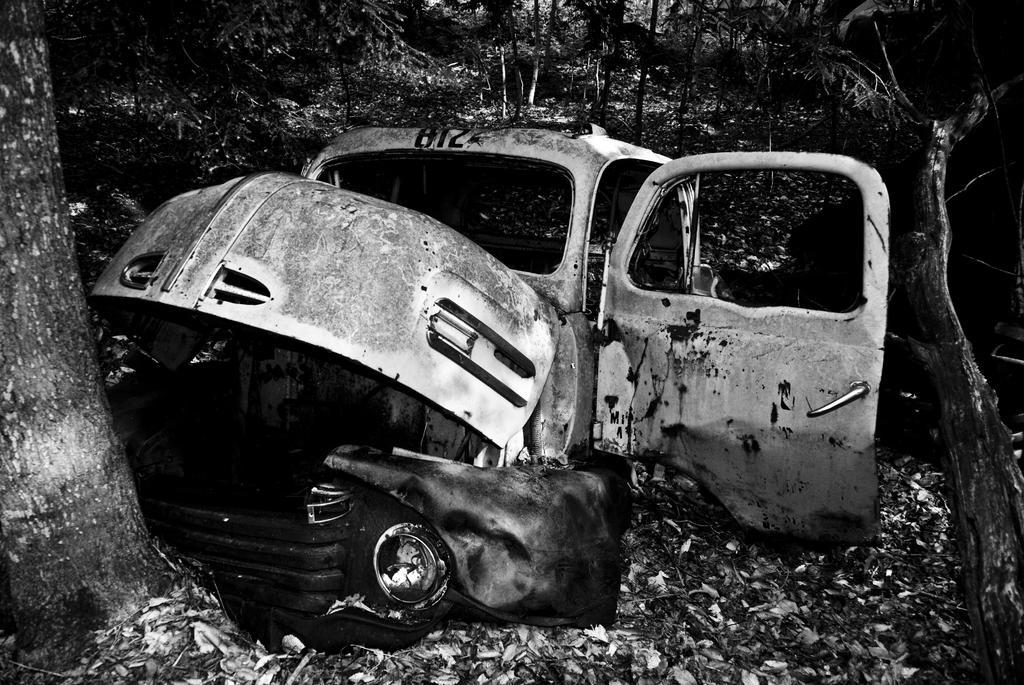In one or two sentences, can you explain what this image depicts? It is a black and white picture. In the center of the image we can see one vehicle. In the background, we can see trees, dry leaves and a few other objects. 